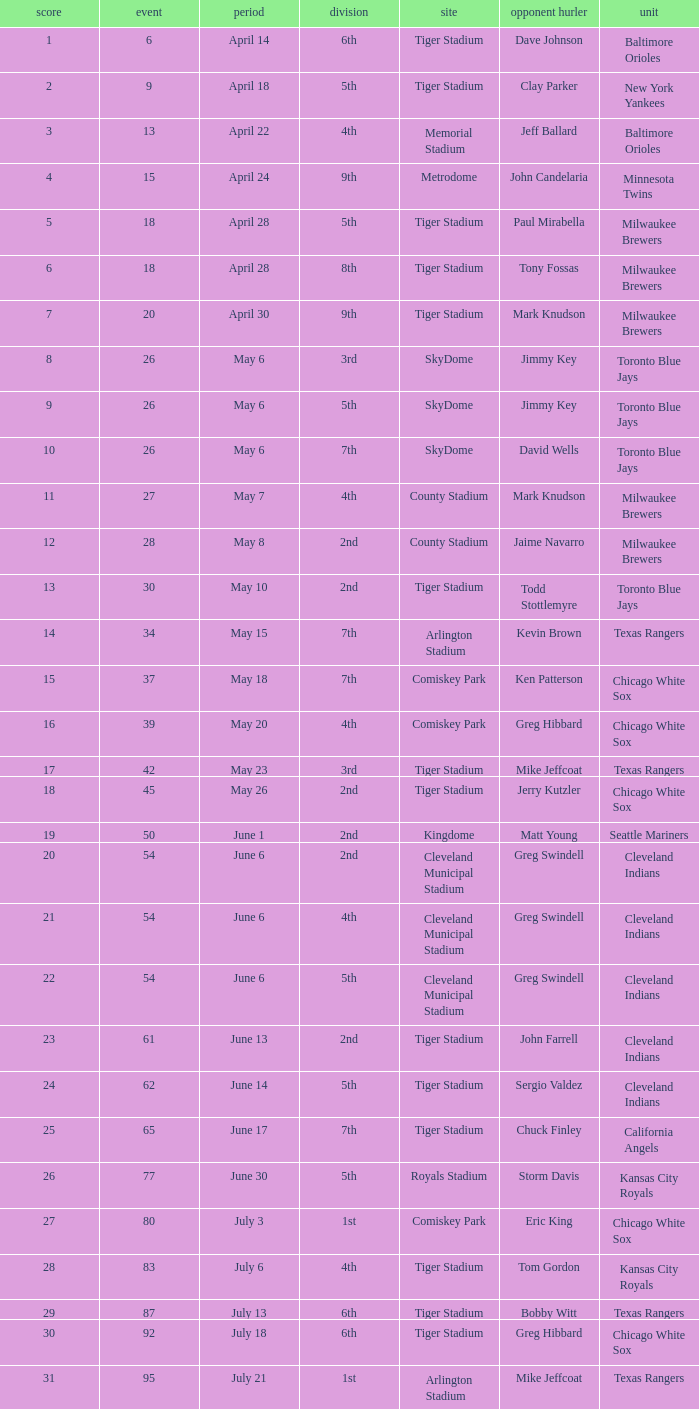On June 17 in Tiger stadium, what was the average home run? 25.0. 